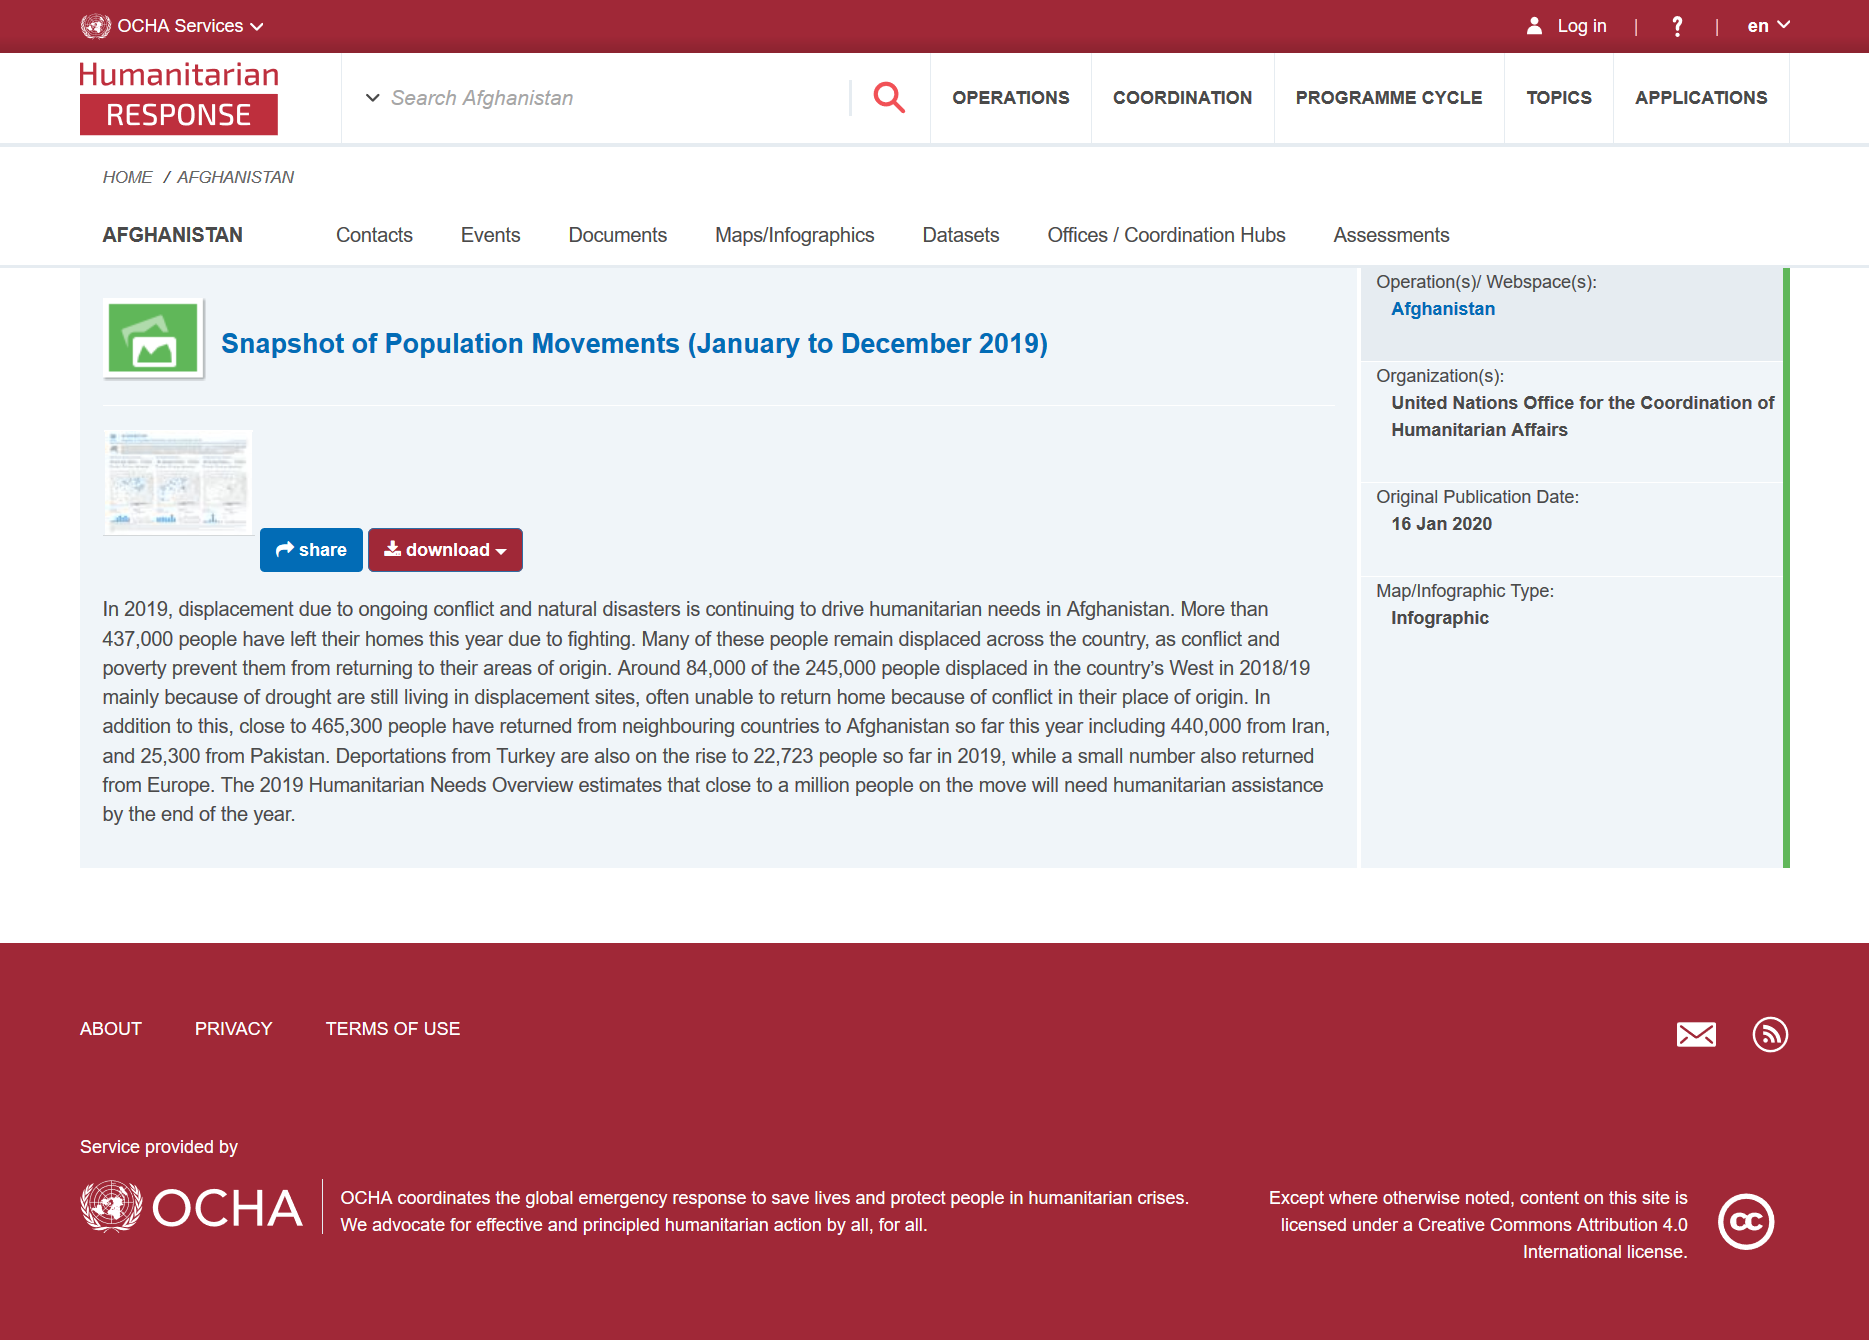Draw attention to some important aspects in this diagram. The statistics provided were recorded for the year 2019. In Afghanistan, a large number of people, exceeding 437,000, were forced to leave their homes due to the ongoing fighting. This snapshot can be downloaded and shared. 